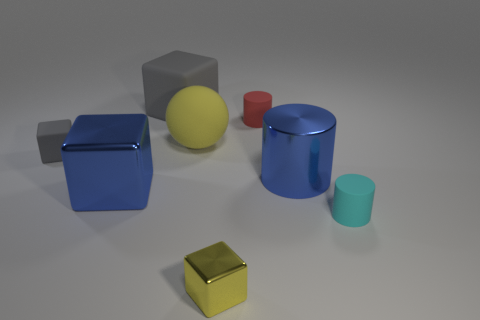There is a small thing that is the same color as the large matte block; what shape is it?
Your answer should be compact. Cube. There is a blue object that is the same shape as the yellow metallic object; what is its material?
Your answer should be compact. Metal. What material is the gray block that is to the right of the metallic thing on the left side of the small metallic thing?
Keep it short and to the point. Rubber. There is a big matte thing in front of the small red cylinder; is its shape the same as the metallic object that is in front of the cyan rubber cylinder?
Keep it short and to the point. No. Are there the same number of metallic things that are in front of the tiny cyan cylinder and small rubber objects?
Keep it short and to the point. No. There is a yellow thing behind the cyan matte object; is there a small gray rubber thing that is on the right side of it?
Offer a very short reply. No. Is there anything else that is the same color as the small matte block?
Provide a succinct answer. Yes. Does the big thing that is behind the yellow matte sphere have the same material as the yellow sphere?
Ensure brevity in your answer.  Yes. Is the number of metal things in front of the large blue cube the same as the number of blue shiny things that are right of the cyan matte thing?
Keep it short and to the point. No. There is a gray rubber thing that is in front of the small thing that is behind the small gray object; what size is it?
Provide a succinct answer. Small. 